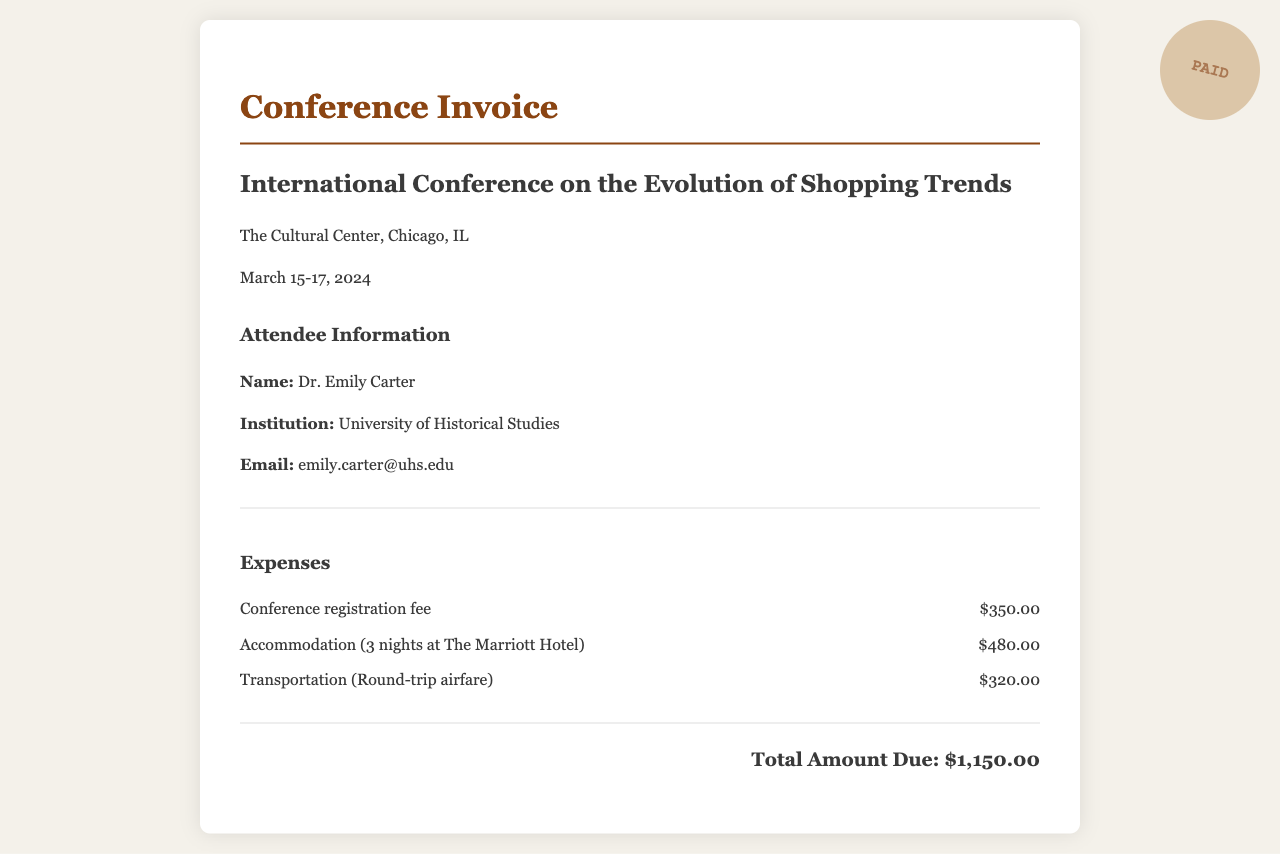what is the name of the conference? The name of the conference is located in the document's header section, stating it clearly.
Answer: International Conference on the Evolution of Shopping Trends where is the conference held? The location is provided in the conference details section.
Answer: The Cultural Center, Chicago, IL how much is the conference registration fee? The registration fee is listed under the expenses section.
Answer: $350.00 how many nights of accommodation are covered? The accommodation details specify the duration of the stay.
Answer: 3 nights what is the total amount due? The total amount due is summed in the invoice at the end of the expenses section.
Answer: $1,150.00 who is the attendee? The attendee's name is mentioned under the attendee information section in the document.
Answer: Dr. Emily Carter what transportation mode is used for the expenses? The transportation type is specified in the expenses section describing the airfare.
Answer: Round-trip airfare which hotel is mentioned for accommodation? The hotel name is specified within the accommodation expense item.
Answer: The Marriott Hotel 